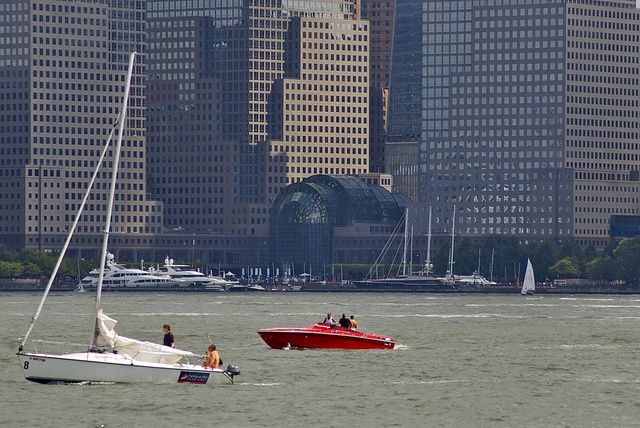Describe the objects in this image and their specific colors. I can see boat in purple, darkgray, white, and gray tones, boat in purple, maroon, black, and red tones, boat in purple, darkgray, gray, navy, and lightgray tones, boat in purple, navy, gray, and darkgray tones, and boat in purple, darkgray, gray, and navy tones in this image. 